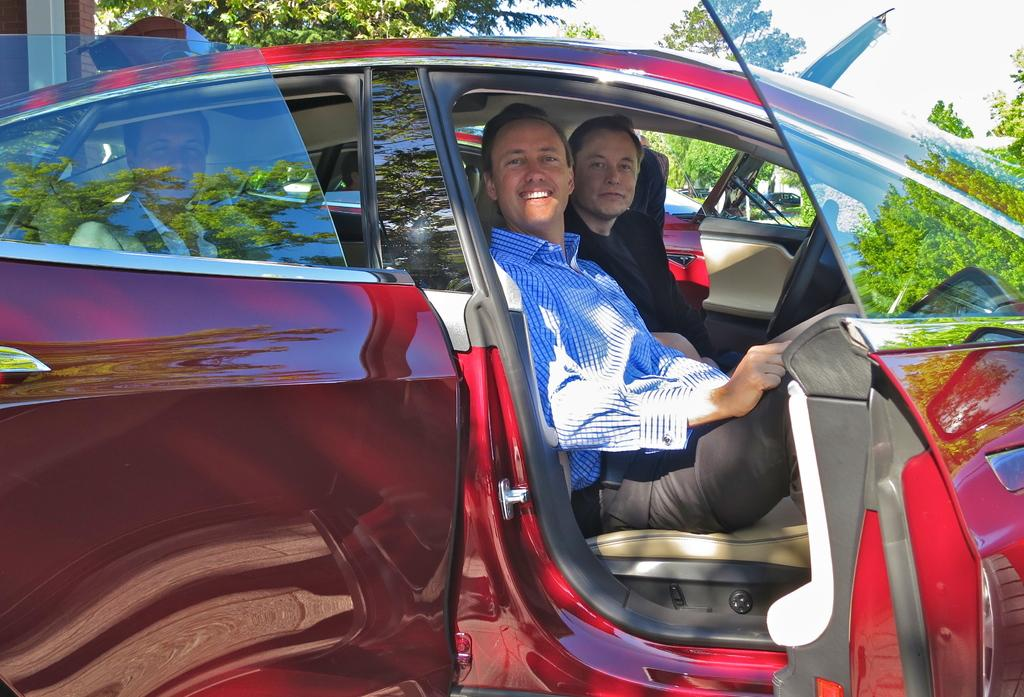How many people are in the image? There are three men in the image. What are the men doing in the image? The men are sitting inside a car and posing for a photo. What can be seen behind the car in the image? There are trees behind the car. What type of unit is being used by the band in the image? There is no band present in the image, and therefore no unit being used by them. 